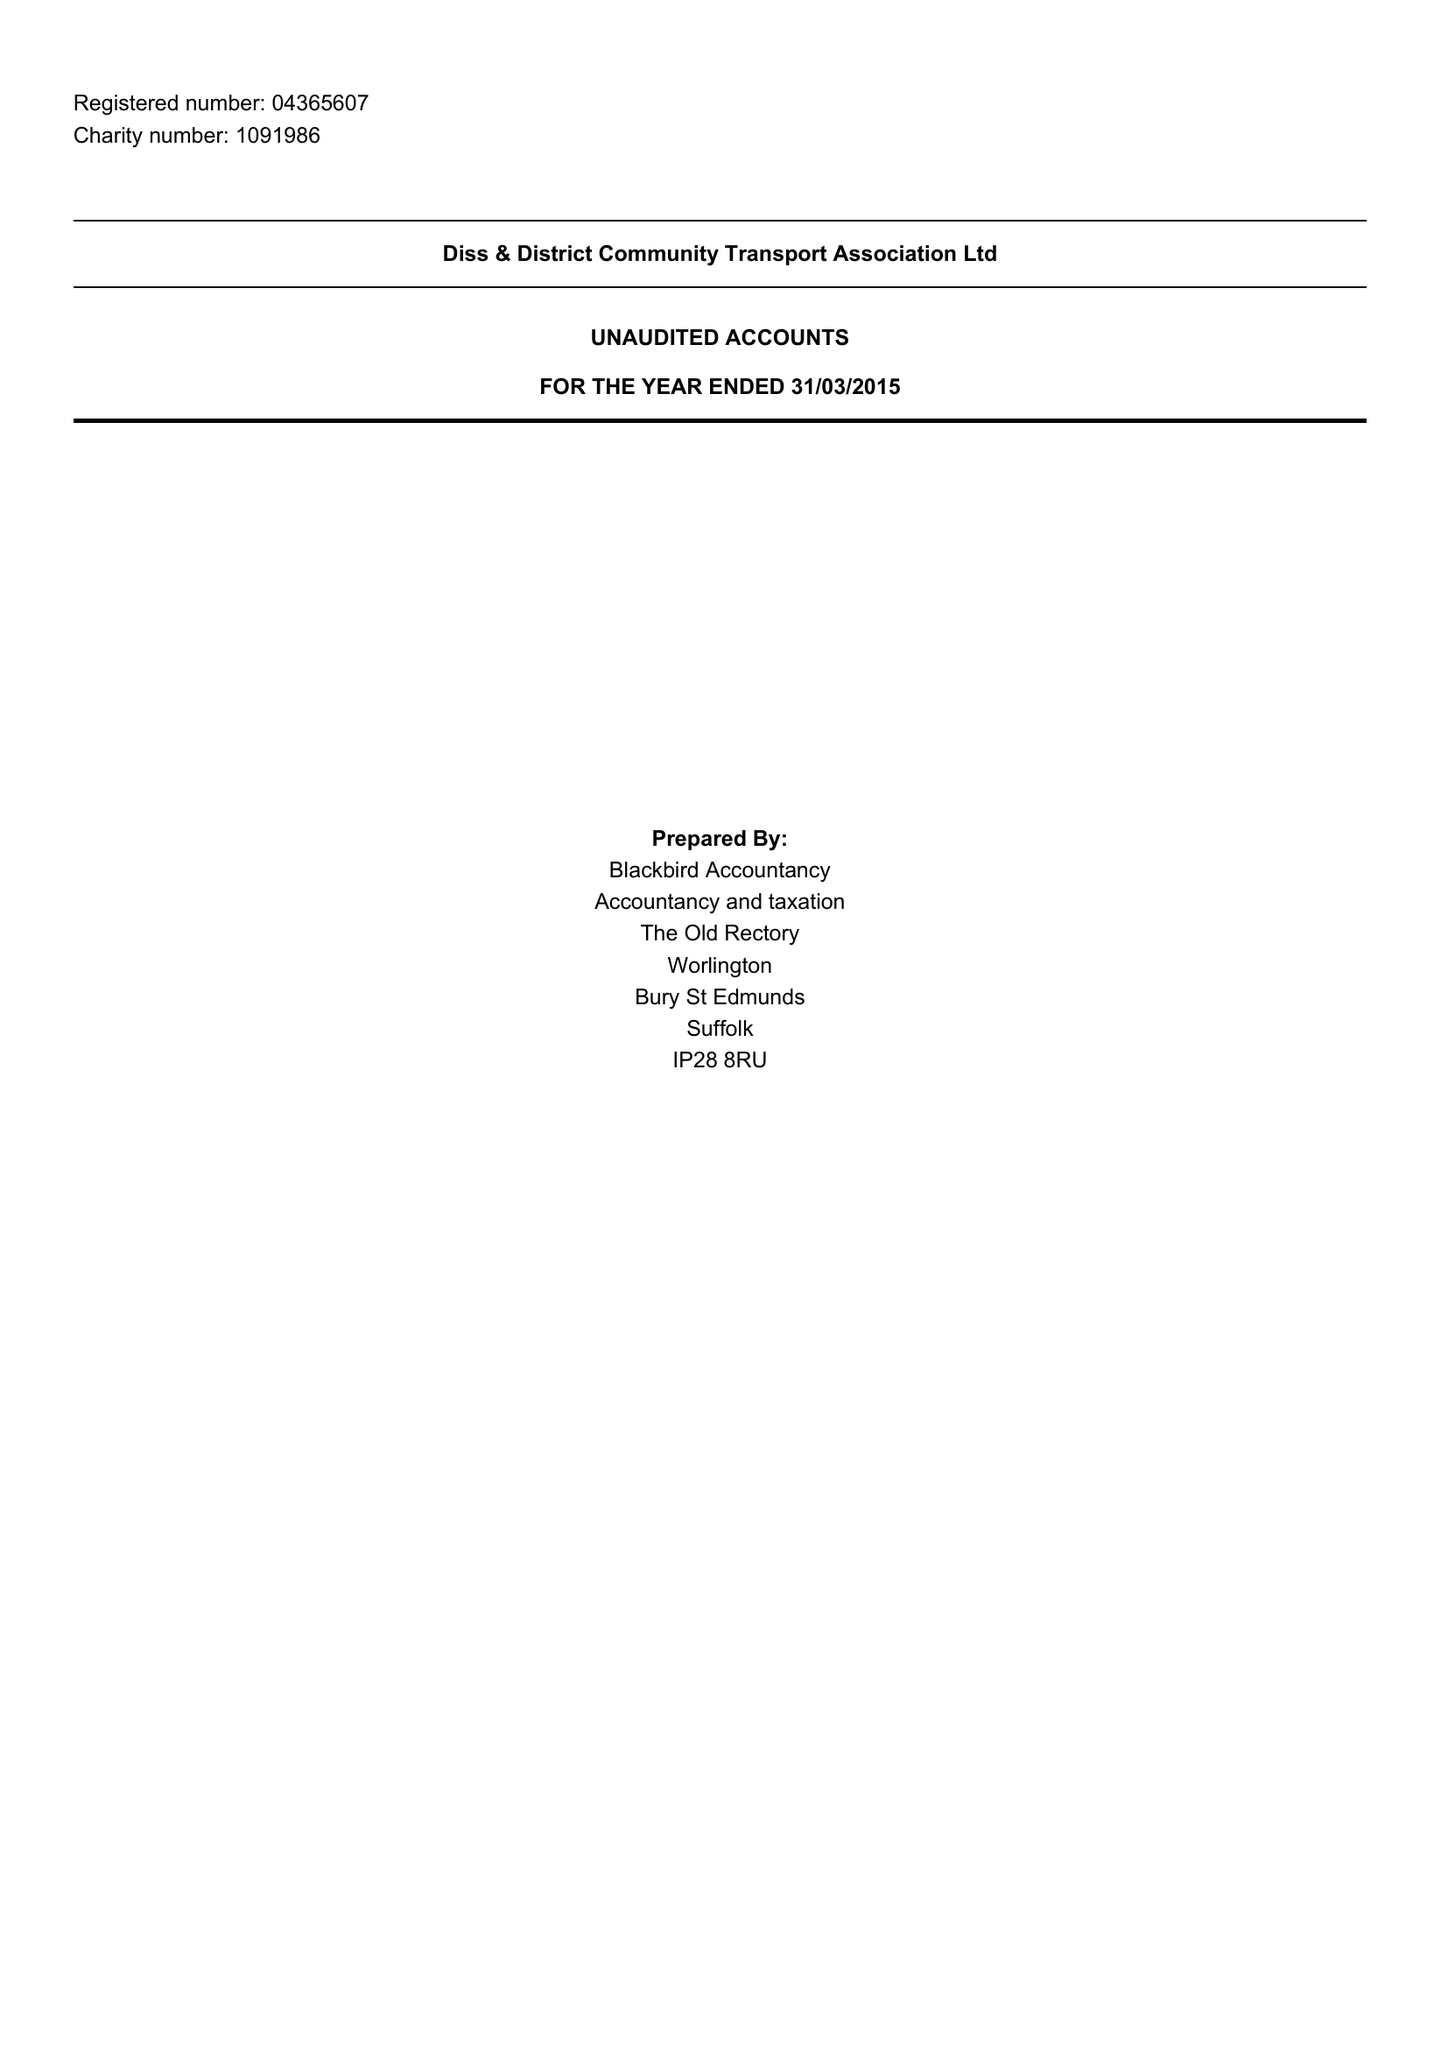What is the value for the income_annually_in_british_pounds?
Answer the question using a single word or phrase. 273772.00 